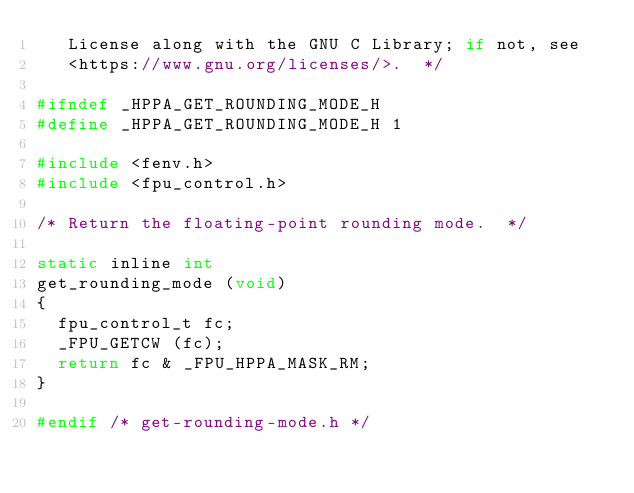<code> <loc_0><loc_0><loc_500><loc_500><_C_>   License along with the GNU C Library; if not, see
   <https://www.gnu.org/licenses/>.  */

#ifndef _HPPA_GET_ROUNDING_MODE_H
#define _HPPA_GET_ROUNDING_MODE_H	1

#include <fenv.h>
#include <fpu_control.h>

/* Return the floating-point rounding mode.  */

static inline int
get_rounding_mode (void)
{
  fpu_control_t fc;
  _FPU_GETCW (fc);
  return fc & _FPU_HPPA_MASK_RM;
}

#endif /* get-rounding-mode.h */
</code> 